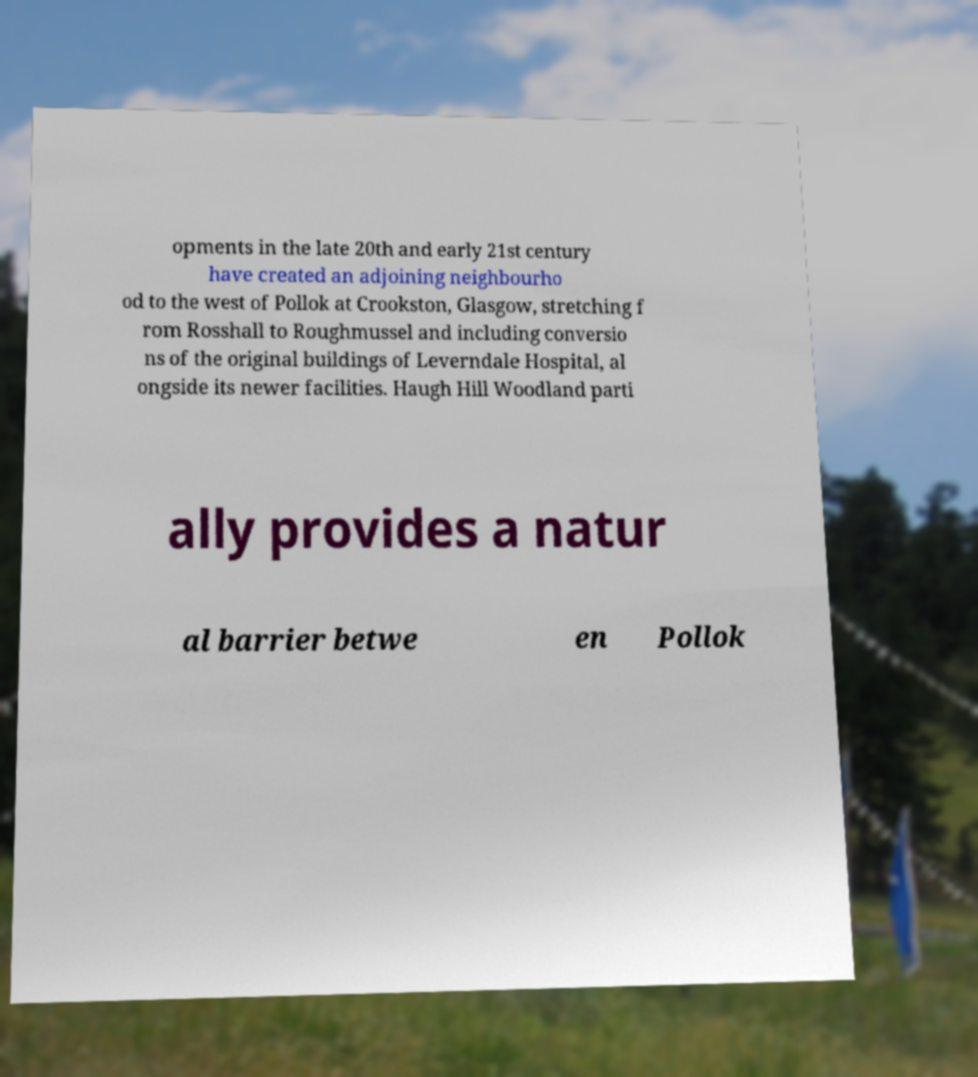Can you read and provide the text displayed in the image?This photo seems to have some interesting text. Can you extract and type it out for me? opments in the late 20th and early 21st century have created an adjoining neighbourho od to the west of Pollok at Crookston, Glasgow, stretching f rom Rosshall to Roughmussel and including conversio ns of the original buildings of Leverndale Hospital, al ongside its newer facilities. Haugh Hill Woodland parti ally provides a natur al barrier betwe en Pollok 